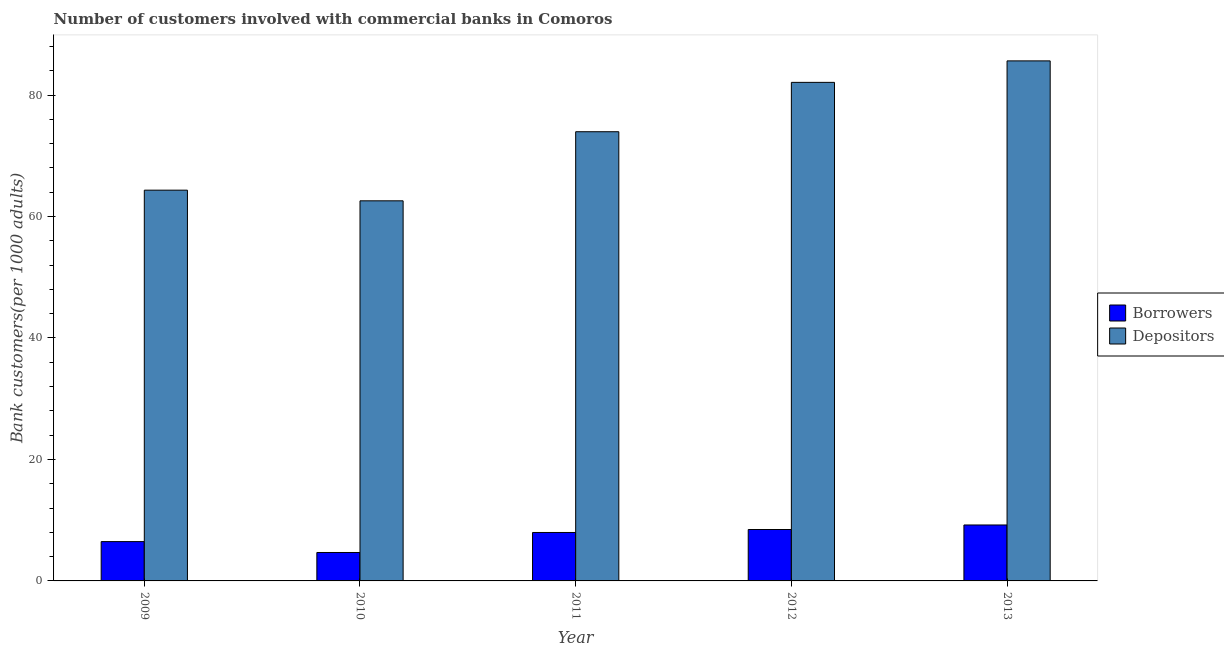How many different coloured bars are there?
Make the answer very short. 2. Are the number of bars per tick equal to the number of legend labels?
Your response must be concise. Yes. Are the number of bars on each tick of the X-axis equal?
Provide a short and direct response. Yes. How many bars are there on the 1st tick from the left?
Your answer should be compact. 2. How many bars are there on the 3rd tick from the right?
Your answer should be compact. 2. What is the number of depositors in 2013?
Provide a succinct answer. 85.63. Across all years, what is the maximum number of borrowers?
Make the answer very short. 9.21. Across all years, what is the minimum number of depositors?
Provide a short and direct response. 62.59. In which year was the number of depositors minimum?
Keep it short and to the point. 2010. What is the total number of borrowers in the graph?
Offer a very short reply. 36.81. What is the difference between the number of depositors in 2009 and that in 2010?
Provide a short and direct response. 1.75. What is the difference between the number of borrowers in 2011 and the number of depositors in 2009?
Keep it short and to the point. 1.5. What is the average number of depositors per year?
Your answer should be compact. 73.72. In the year 2013, what is the difference between the number of depositors and number of borrowers?
Keep it short and to the point. 0. What is the ratio of the number of depositors in 2009 to that in 2013?
Provide a short and direct response. 0.75. What is the difference between the highest and the second highest number of depositors?
Give a very brief answer. 3.54. What is the difference between the highest and the lowest number of depositors?
Keep it short and to the point. 23.04. Is the sum of the number of depositors in 2011 and 2013 greater than the maximum number of borrowers across all years?
Give a very brief answer. Yes. What does the 2nd bar from the left in 2012 represents?
Provide a short and direct response. Depositors. What does the 1st bar from the right in 2010 represents?
Ensure brevity in your answer.  Depositors. How many years are there in the graph?
Your answer should be compact. 5. What is the difference between two consecutive major ticks on the Y-axis?
Your answer should be very brief. 20. Are the values on the major ticks of Y-axis written in scientific E-notation?
Your answer should be compact. No. What is the title of the graph?
Your answer should be very brief. Number of customers involved with commercial banks in Comoros. Does "Registered firms" appear as one of the legend labels in the graph?
Make the answer very short. No. What is the label or title of the X-axis?
Provide a short and direct response. Year. What is the label or title of the Y-axis?
Offer a very short reply. Bank customers(per 1000 adults). What is the Bank customers(per 1000 adults) of Borrowers in 2009?
Give a very brief answer. 6.48. What is the Bank customers(per 1000 adults) in Depositors in 2009?
Give a very brief answer. 64.34. What is the Bank customers(per 1000 adults) in Borrowers in 2010?
Your answer should be compact. 4.68. What is the Bank customers(per 1000 adults) of Depositors in 2010?
Your answer should be very brief. 62.59. What is the Bank customers(per 1000 adults) in Borrowers in 2011?
Make the answer very short. 7.98. What is the Bank customers(per 1000 adults) in Depositors in 2011?
Keep it short and to the point. 73.96. What is the Bank customers(per 1000 adults) in Borrowers in 2012?
Your answer should be compact. 8.47. What is the Bank customers(per 1000 adults) of Depositors in 2012?
Keep it short and to the point. 82.09. What is the Bank customers(per 1000 adults) of Borrowers in 2013?
Give a very brief answer. 9.21. What is the Bank customers(per 1000 adults) in Depositors in 2013?
Your response must be concise. 85.63. Across all years, what is the maximum Bank customers(per 1000 adults) of Borrowers?
Offer a terse response. 9.21. Across all years, what is the maximum Bank customers(per 1000 adults) of Depositors?
Keep it short and to the point. 85.63. Across all years, what is the minimum Bank customers(per 1000 adults) of Borrowers?
Offer a terse response. 4.68. Across all years, what is the minimum Bank customers(per 1000 adults) in Depositors?
Provide a succinct answer. 62.59. What is the total Bank customers(per 1000 adults) in Borrowers in the graph?
Your answer should be compact. 36.81. What is the total Bank customers(per 1000 adults) of Depositors in the graph?
Make the answer very short. 368.62. What is the difference between the Bank customers(per 1000 adults) of Borrowers in 2009 and that in 2010?
Provide a short and direct response. 1.79. What is the difference between the Bank customers(per 1000 adults) of Depositors in 2009 and that in 2010?
Your response must be concise. 1.75. What is the difference between the Bank customers(per 1000 adults) in Borrowers in 2009 and that in 2011?
Offer a very short reply. -1.5. What is the difference between the Bank customers(per 1000 adults) in Depositors in 2009 and that in 2011?
Offer a very short reply. -9.62. What is the difference between the Bank customers(per 1000 adults) in Borrowers in 2009 and that in 2012?
Ensure brevity in your answer.  -1.99. What is the difference between the Bank customers(per 1000 adults) in Depositors in 2009 and that in 2012?
Your response must be concise. -17.75. What is the difference between the Bank customers(per 1000 adults) in Borrowers in 2009 and that in 2013?
Offer a terse response. -2.74. What is the difference between the Bank customers(per 1000 adults) in Depositors in 2009 and that in 2013?
Your answer should be compact. -21.29. What is the difference between the Bank customers(per 1000 adults) in Borrowers in 2010 and that in 2011?
Ensure brevity in your answer.  -3.3. What is the difference between the Bank customers(per 1000 adults) of Depositors in 2010 and that in 2011?
Your response must be concise. -11.38. What is the difference between the Bank customers(per 1000 adults) of Borrowers in 2010 and that in 2012?
Ensure brevity in your answer.  -3.78. What is the difference between the Bank customers(per 1000 adults) in Depositors in 2010 and that in 2012?
Your response must be concise. -19.5. What is the difference between the Bank customers(per 1000 adults) of Borrowers in 2010 and that in 2013?
Your answer should be very brief. -4.53. What is the difference between the Bank customers(per 1000 adults) in Depositors in 2010 and that in 2013?
Offer a terse response. -23.04. What is the difference between the Bank customers(per 1000 adults) of Borrowers in 2011 and that in 2012?
Offer a terse response. -0.49. What is the difference between the Bank customers(per 1000 adults) of Depositors in 2011 and that in 2012?
Provide a short and direct response. -8.13. What is the difference between the Bank customers(per 1000 adults) in Borrowers in 2011 and that in 2013?
Provide a succinct answer. -1.23. What is the difference between the Bank customers(per 1000 adults) of Depositors in 2011 and that in 2013?
Your response must be concise. -11.66. What is the difference between the Bank customers(per 1000 adults) in Borrowers in 2012 and that in 2013?
Provide a succinct answer. -0.75. What is the difference between the Bank customers(per 1000 adults) in Depositors in 2012 and that in 2013?
Provide a short and direct response. -3.54. What is the difference between the Bank customers(per 1000 adults) in Borrowers in 2009 and the Bank customers(per 1000 adults) in Depositors in 2010?
Offer a terse response. -56.11. What is the difference between the Bank customers(per 1000 adults) of Borrowers in 2009 and the Bank customers(per 1000 adults) of Depositors in 2011?
Keep it short and to the point. -67.49. What is the difference between the Bank customers(per 1000 adults) in Borrowers in 2009 and the Bank customers(per 1000 adults) in Depositors in 2012?
Give a very brief answer. -75.62. What is the difference between the Bank customers(per 1000 adults) of Borrowers in 2009 and the Bank customers(per 1000 adults) of Depositors in 2013?
Ensure brevity in your answer.  -79.15. What is the difference between the Bank customers(per 1000 adults) in Borrowers in 2010 and the Bank customers(per 1000 adults) in Depositors in 2011?
Give a very brief answer. -69.28. What is the difference between the Bank customers(per 1000 adults) of Borrowers in 2010 and the Bank customers(per 1000 adults) of Depositors in 2012?
Ensure brevity in your answer.  -77.41. What is the difference between the Bank customers(per 1000 adults) of Borrowers in 2010 and the Bank customers(per 1000 adults) of Depositors in 2013?
Give a very brief answer. -80.95. What is the difference between the Bank customers(per 1000 adults) of Borrowers in 2011 and the Bank customers(per 1000 adults) of Depositors in 2012?
Keep it short and to the point. -74.11. What is the difference between the Bank customers(per 1000 adults) of Borrowers in 2011 and the Bank customers(per 1000 adults) of Depositors in 2013?
Provide a short and direct response. -77.65. What is the difference between the Bank customers(per 1000 adults) of Borrowers in 2012 and the Bank customers(per 1000 adults) of Depositors in 2013?
Your response must be concise. -77.16. What is the average Bank customers(per 1000 adults) in Borrowers per year?
Offer a terse response. 7.36. What is the average Bank customers(per 1000 adults) of Depositors per year?
Your answer should be compact. 73.72. In the year 2009, what is the difference between the Bank customers(per 1000 adults) of Borrowers and Bank customers(per 1000 adults) of Depositors?
Provide a short and direct response. -57.87. In the year 2010, what is the difference between the Bank customers(per 1000 adults) of Borrowers and Bank customers(per 1000 adults) of Depositors?
Keep it short and to the point. -57.91. In the year 2011, what is the difference between the Bank customers(per 1000 adults) of Borrowers and Bank customers(per 1000 adults) of Depositors?
Offer a very short reply. -65.99. In the year 2012, what is the difference between the Bank customers(per 1000 adults) of Borrowers and Bank customers(per 1000 adults) of Depositors?
Keep it short and to the point. -73.63. In the year 2013, what is the difference between the Bank customers(per 1000 adults) of Borrowers and Bank customers(per 1000 adults) of Depositors?
Your answer should be very brief. -76.42. What is the ratio of the Bank customers(per 1000 adults) in Borrowers in 2009 to that in 2010?
Offer a terse response. 1.38. What is the ratio of the Bank customers(per 1000 adults) in Depositors in 2009 to that in 2010?
Ensure brevity in your answer.  1.03. What is the ratio of the Bank customers(per 1000 adults) in Borrowers in 2009 to that in 2011?
Your answer should be compact. 0.81. What is the ratio of the Bank customers(per 1000 adults) in Depositors in 2009 to that in 2011?
Make the answer very short. 0.87. What is the ratio of the Bank customers(per 1000 adults) of Borrowers in 2009 to that in 2012?
Provide a short and direct response. 0.76. What is the ratio of the Bank customers(per 1000 adults) of Depositors in 2009 to that in 2012?
Make the answer very short. 0.78. What is the ratio of the Bank customers(per 1000 adults) in Borrowers in 2009 to that in 2013?
Keep it short and to the point. 0.7. What is the ratio of the Bank customers(per 1000 adults) of Depositors in 2009 to that in 2013?
Your response must be concise. 0.75. What is the ratio of the Bank customers(per 1000 adults) of Borrowers in 2010 to that in 2011?
Keep it short and to the point. 0.59. What is the ratio of the Bank customers(per 1000 adults) of Depositors in 2010 to that in 2011?
Keep it short and to the point. 0.85. What is the ratio of the Bank customers(per 1000 adults) in Borrowers in 2010 to that in 2012?
Make the answer very short. 0.55. What is the ratio of the Bank customers(per 1000 adults) of Depositors in 2010 to that in 2012?
Your answer should be very brief. 0.76. What is the ratio of the Bank customers(per 1000 adults) of Borrowers in 2010 to that in 2013?
Your answer should be compact. 0.51. What is the ratio of the Bank customers(per 1000 adults) of Depositors in 2010 to that in 2013?
Keep it short and to the point. 0.73. What is the ratio of the Bank customers(per 1000 adults) of Borrowers in 2011 to that in 2012?
Provide a succinct answer. 0.94. What is the ratio of the Bank customers(per 1000 adults) in Depositors in 2011 to that in 2012?
Provide a short and direct response. 0.9. What is the ratio of the Bank customers(per 1000 adults) of Borrowers in 2011 to that in 2013?
Provide a succinct answer. 0.87. What is the ratio of the Bank customers(per 1000 adults) in Depositors in 2011 to that in 2013?
Offer a terse response. 0.86. What is the ratio of the Bank customers(per 1000 adults) in Borrowers in 2012 to that in 2013?
Offer a terse response. 0.92. What is the ratio of the Bank customers(per 1000 adults) of Depositors in 2012 to that in 2013?
Your answer should be very brief. 0.96. What is the difference between the highest and the second highest Bank customers(per 1000 adults) of Borrowers?
Offer a very short reply. 0.75. What is the difference between the highest and the second highest Bank customers(per 1000 adults) in Depositors?
Keep it short and to the point. 3.54. What is the difference between the highest and the lowest Bank customers(per 1000 adults) in Borrowers?
Your answer should be very brief. 4.53. What is the difference between the highest and the lowest Bank customers(per 1000 adults) of Depositors?
Ensure brevity in your answer.  23.04. 